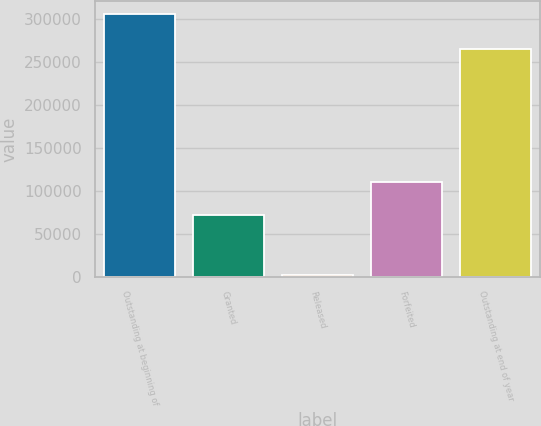<chart> <loc_0><loc_0><loc_500><loc_500><bar_chart><fcel>Outstanding at beginning of<fcel>Granted<fcel>Released<fcel>Forfeited<fcel>Outstanding at end of year<nl><fcel>306261<fcel>72470<fcel>1802<fcel>111100<fcel>265829<nl></chart> 